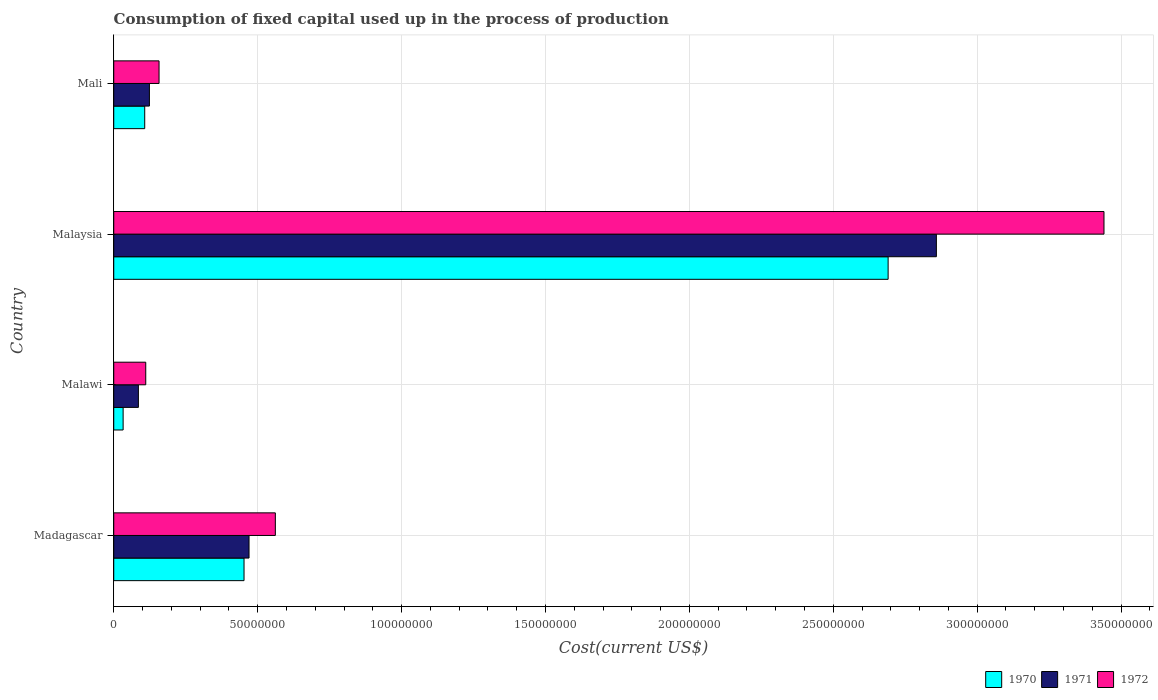How many different coloured bars are there?
Keep it short and to the point. 3. What is the label of the 4th group of bars from the top?
Provide a short and direct response. Madagascar. In how many cases, is the number of bars for a given country not equal to the number of legend labels?
Ensure brevity in your answer.  0. What is the amount consumed in the process of production in 1972 in Mali?
Your response must be concise. 1.57e+07. Across all countries, what is the maximum amount consumed in the process of production in 1971?
Give a very brief answer. 2.86e+08. Across all countries, what is the minimum amount consumed in the process of production in 1970?
Keep it short and to the point. 3.26e+06. In which country was the amount consumed in the process of production in 1970 maximum?
Give a very brief answer. Malaysia. In which country was the amount consumed in the process of production in 1971 minimum?
Your answer should be compact. Malawi. What is the total amount consumed in the process of production in 1970 in the graph?
Your response must be concise. 3.28e+08. What is the difference between the amount consumed in the process of production in 1972 in Madagascar and that in Mali?
Your answer should be compact. 4.04e+07. What is the difference between the amount consumed in the process of production in 1972 in Malaysia and the amount consumed in the process of production in 1971 in Madagascar?
Offer a very short reply. 2.97e+08. What is the average amount consumed in the process of production in 1972 per country?
Your response must be concise. 1.07e+08. What is the difference between the amount consumed in the process of production in 1972 and amount consumed in the process of production in 1970 in Madagascar?
Ensure brevity in your answer.  1.09e+07. In how many countries, is the amount consumed in the process of production in 1972 greater than 60000000 US$?
Your answer should be very brief. 1. What is the ratio of the amount consumed in the process of production in 1970 in Malawi to that in Malaysia?
Ensure brevity in your answer.  0.01. Is the amount consumed in the process of production in 1972 in Malawi less than that in Mali?
Your answer should be compact. Yes. Is the difference between the amount consumed in the process of production in 1972 in Malawi and Mali greater than the difference between the amount consumed in the process of production in 1970 in Malawi and Mali?
Your answer should be very brief. Yes. What is the difference between the highest and the second highest amount consumed in the process of production in 1972?
Provide a succinct answer. 2.88e+08. What is the difference between the highest and the lowest amount consumed in the process of production in 1970?
Offer a very short reply. 2.66e+08. In how many countries, is the amount consumed in the process of production in 1970 greater than the average amount consumed in the process of production in 1970 taken over all countries?
Offer a very short reply. 1. What does the 2nd bar from the top in Malawi represents?
Ensure brevity in your answer.  1971. Is it the case that in every country, the sum of the amount consumed in the process of production in 1971 and amount consumed in the process of production in 1970 is greater than the amount consumed in the process of production in 1972?
Your response must be concise. Yes. How many bars are there?
Your response must be concise. 12. How many countries are there in the graph?
Offer a very short reply. 4. What is the difference between two consecutive major ticks on the X-axis?
Provide a succinct answer. 5.00e+07. Does the graph contain any zero values?
Keep it short and to the point. No. Does the graph contain grids?
Offer a very short reply. Yes. Where does the legend appear in the graph?
Keep it short and to the point. Bottom right. How are the legend labels stacked?
Give a very brief answer. Horizontal. What is the title of the graph?
Provide a short and direct response. Consumption of fixed capital used up in the process of production. Does "1966" appear as one of the legend labels in the graph?
Your response must be concise. No. What is the label or title of the X-axis?
Offer a very short reply. Cost(current US$). What is the Cost(current US$) in 1970 in Madagascar?
Your answer should be very brief. 4.53e+07. What is the Cost(current US$) of 1971 in Madagascar?
Keep it short and to the point. 4.70e+07. What is the Cost(current US$) of 1972 in Madagascar?
Give a very brief answer. 5.61e+07. What is the Cost(current US$) of 1970 in Malawi?
Your response must be concise. 3.26e+06. What is the Cost(current US$) in 1971 in Malawi?
Make the answer very short. 8.56e+06. What is the Cost(current US$) in 1972 in Malawi?
Keep it short and to the point. 1.11e+07. What is the Cost(current US$) in 1970 in Malaysia?
Your response must be concise. 2.69e+08. What is the Cost(current US$) in 1971 in Malaysia?
Offer a terse response. 2.86e+08. What is the Cost(current US$) in 1972 in Malaysia?
Provide a succinct answer. 3.44e+08. What is the Cost(current US$) of 1970 in Mali?
Keep it short and to the point. 1.08e+07. What is the Cost(current US$) of 1971 in Mali?
Give a very brief answer. 1.24e+07. What is the Cost(current US$) of 1972 in Mali?
Your response must be concise. 1.57e+07. Across all countries, what is the maximum Cost(current US$) in 1970?
Ensure brevity in your answer.  2.69e+08. Across all countries, what is the maximum Cost(current US$) of 1971?
Your answer should be compact. 2.86e+08. Across all countries, what is the maximum Cost(current US$) of 1972?
Provide a short and direct response. 3.44e+08. Across all countries, what is the minimum Cost(current US$) in 1970?
Provide a succinct answer. 3.26e+06. Across all countries, what is the minimum Cost(current US$) of 1971?
Make the answer very short. 8.56e+06. Across all countries, what is the minimum Cost(current US$) of 1972?
Offer a very short reply. 1.11e+07. What is the total Cost(current US$) of 1970 in the graph?
Provide a succinct answer. 3.28e+08. What is the total Cost(current US$) of 1971 in the graph?
Keep it short and to the point. 3.54e+08. What is the total Cost(current US$) in 1972 in the graph?
Your response must be concise. 4.27e+08. What is the difference between the Cost(current US$) of 1970 in Madagascar and that in Malawi?
Your response must be concise. 4.20e+07. What is the difference between the Cost(current US$) in 1971 in Madagascar and that in Malawi?
Ensure brevity in your answer.  3.84e+07. What is the difference between the Cost(current US$) in 1972 in Madagascar and that in Malawi?
Make the answer very short. 4.50e+07. What is the difference between the Cost(current US$) of 1970 in Madagascar and that in Malaysia?
Provide a short and direct response. -2.24e+08. What is the difference between the Cost(current US$) of 1971 in Madagascar and that in Malaysia?
Offer a very short reply. -2.39e+08. What is the difference between the Cost(current US$) in 1972 in Madagascar and that in Malaysia?
Give a very brief answer. -2.88e+08. What is the difference between the Cost(current US$) of 1970 in Madagascar and that in Mali?
Offer a very short reply. 3.45e+07. What is the difference between the Cost(current US$) in 1971 in Madagascar and that in Mali?
Ensure brevity in your answer.  3.46e+07. What is the difference between the Cost(current US$) of 1972 in Madagascar and that in Mali?
Make the answer very short. 4.04e+07. What is the difference between the Cost(current US$) of 1970 in Malawi and that in Malaysia?
Your response must be concise. -2.66e+08. What is the difference between the Cost(current US$) of 1971 in Malawi and that in Malaysia?
Offer a terse response. -2.77e+08. What is the difference between the Cost(current US$) of 1972 in Malawi and that in Malaysia?
Ensure brevity in your answer.  -3.33e+08. What is the difference between the Cost(current US$) in 1970 in Malawi and that in Mali?
Provide a short and direct response. -7.50e+06. What is the difference between the Cost(current US$) in 1971 in Malawi and that in Mali?
Your response must be concise. -3.83e+06. What is the difference between the Cost(current US$) of 1972 in Malawi and that in Mali?
Make the answer very short. -4.62e+06. What is the difference between the Cost(current US$) in 1970 in Malaysia and that in Mali?
Your answer should be compact. 2.58e+08. What is the difference between the Cost(current US$) in 1971 in Malaysia and that in Mali?
Your response must be concise. 2.73e+08. What is the difference between the Cost(current US$) in 1972 in Malaysia and that in Mali?
Offer a terse response. 3.28e+08. What is the difference between the Cost(current US$) in 1970 in Madagascar and the Cost(current US$) in 1971 in Malawi?
Keep it short and to the point. 3.67e+07. What is the difference between the Cost(current US$) of 1970 in Madagascar and the Cost(current US$) of 1972 in Malawi?
Provide a succinct answer. 3.41e+07. What is the difference between the Cost(current US$) in 1971 in Madagascar and the Cost(current US$) in 1972 in Malawi?
Make the answer very short. 3.59e+07. What is the difference between the Cost(current US$) of 1970 in Madagascar and the Cost(current US$) of 1971 in Malaysia?
Your response must be concise. -2.41e+08. What is the difference between the Cost(current US$) in 1970 in Madagascar and the Cost(current US$) in 1972 in Malaysia?
Provide a succinct answer. -2.99e+08. What is the difference between the Cost(current US$) in 1971 in Madagascar and the Cost(current US$) in 1972 in Malaysia?
Your answer should be very brief. -2.97e+08. What is the difference between the Cost(current US$) in 1970 in Madagascar and the Cost(current US$) in 1971 in Mali?
Offer a very short reply. 3.29e+07. What is the difference between the Cost(current US$) in 1970 in Madagascar and the Cost(current US$) in 1972 in Mali?
Your answer should be compact. 2.95e+07. What is the difference between the Cost(current US$) of 1971 in Madagascar and the Cost(current US$) of 1972 in Mali?
Offer a very short reply. 3.13e+07. What is the difference between the Cost(current US$) of 1970 in Malawi and the Cost(current US$) of 1971 in Malaysia?
Your response must be concise. -2.83e+08. What is the difference between the Cost(current US$) in 1970 in Malawi and the Cost(current US$) in 1972 in Malaysia?
Your response must be concise. -3.41e+08. What is the difference between the Cost(current US$) of 1971 in Malawi and the Cost(current US$) of 1972 in Malaysia?
Your response must be concise. -3.35e+08. What is the difference between the Cost(current US$) of 1970 in Malawi and the Cost(current US$) of 1971 in Mali?
Your response must be concise. -9.13e+06. What is the difference between the Cost(current US$) of 1970 in Malawi and the Cost(current US$) of 1972 in Mali?
Your answer should be compact. -1.25e+07. What is the difference between the Cost(current US$) of 1971 in Malawi and the Cost(current US$) of 1972 in Mali?
Provide a succinct answer. -7.18e+06. What is the difference between the Cost(current US$) of 1970 in Malaysia and the Cost(current US$) of 1971 in Mali?
Make the answer very short. 2.57e+08. What is the difference between the Cost(current US$) of 1970 in Malaysia and the Cost(current US$) of 1972 in Mali?
Offer a very short reply. 2.53e+08. What is the difference between the Cost(current US$) of 1971 in Malaysia and the Cost(current US$) of 1972 in Mali?
Provide a succinct answer. 2.70e+08. What is the average Cost(current US$) in 1970 per country?
Offer a terse response. 8.21e+07. What is the average Cost(current US$) in 1971 per country?
Your answer should be compact. 8.84e+07. What is the average Cost(current US$) in 1972 per country?
Your answer should be compact. 1.07e+08. What is the difference between the Cost(current US$) of 1970 and Cost(current US$) of 1971 in Madagascar?
Keep it short and to the point. -1.74e+06. What is the difference between the Cost(current US$) in 1970 and Cost(current US$) in 1972 in Madagascar?
Your answer should be compact. -1.09e+07. What is the difference between the Cost(current US$) in 1971 and Cost(current US$) in 1972 in Madagascar?
Your response must be concise. -9.14e+06. What is the difference between the Cost(current US$) in 1970 and Cost(current US$) in 1971 in Malawi?
Offer a terse response. -5.30e+06. What is the difference between the Cost(current US$) in 1970 and Cost(current US$) in 1972 in Malawi?
Your answer should be compact. -7.86e+06. What is the difference between the Cost(current US$) of 1971 and Cost(current US$) of 1972 in Malawi?
Keep it short and to the point. -2.56e+06. What is the difference between the Cost(current US$) of 1970 and Cost(current US$) of 1971 in Malaysia?
Offer a very short reply. -1.68e+07. What is the difference between the Cost(current US$) in 1970 and Cost(current US$) in 1972 in Malaysia?
Give a very brief answer. -7.50e+07. What is the difference between the Cost(current US$) in 1971 and Cost(current US$) in 1972 in Malaysia?
Make the answer very short. -5.82e+07. What is the difference between the Cost(current US$) in 1970 and Cost(current US$) in 1971 in Mali?
Make the answer very short. -1.63e+06. What is the difference between the Cost(current US$) in 1970 and Cost(current US$) in 1972 in Mali?
Give a very brief answer. -4.98e+06. What is the difference between the Cost(current US$) of 1971 and Cost(current US$) of 1972 in Mali?
Provide a succinct answer. -3.35e+06. What is the ratio of the Cost(current US$) in 1970 in Madagascar to that in Malawi?
Your response must be concise. 13.88. What is the ratio of the Cost(current US$) of 1971 in Madagascar to that in Malawi?
Keep it short and to the point. 5.49. What is the ratio of the Cost(current US$) of 1972 in Madagascar to that in Malawi?
Give a very brief answer. 5.05. What is the ratio of the Cost(current US$) of 1970 in Madagascar to that in Malaysia?
Provide a succinct answer. 0.17. What is the ratio of the Cost(current US$) of 1971 in Madagascar to that in Malaysia?
Keep it short and to the point. 0.16. What is the ratio of the Cost(current US$) in 1972 in Madagascar to that in Malaysia?
Your answer should be compact. 0.16. What is the ratio of the Cost(current US$) of 1970 in Madagascar to that in Mali?
Offer a very short reply. 4.21. What is the ratio of the Cost(current US$) in 1971 in Madagascar to that in Mali?
Provide a succinct answer. 3.79. What is the ratio of the Cost(current US$) in 1972 in Madagascar to that in Mali?
Provide a short and direct response. 3.57. What is the ratio of the Cost(current US$) of 1970 in Malawi to that in Malaysia?
Keep it short and to the point. 0.01. What is the ratio of the Cost(current US$) in 1971 in Malawi to that in Malaysia?
Your response must be concise. 0.03. What is the ratio of the Cost(current US$) in 1972 in Malawi to that in Malaysia?
Provide a short and direct response. 0.03. What is the ratio of the Cost(current US$) in 1970 in Malawi to that in Mali?
Your answer should be very brief. 0.3. What is the ratio of the Cost(current US$) in 1971 in Malawi to that in Mali?
Offer a terse response. 0.69. What is the ratio of the Cost(current US$) of 1972 in Malawi to that in Mali?
Provide a succinct answer. 0.71. What is the ratio of the Cost(current US$) of 1970 in Malaysia to that in Mali?
Your answer should be very brief. 25. What is the ratio of the Cost(current US$) of 1971 in Malaysia to that in Mali?
Your response must be concise. 23.06. What is the ratio of the Cost(current US$) of 1972 in Malaysia to that in Mali?
Offer a very short reply. 21.86. What is the difference between the highest and the second highest Cost(current US$) in 1970?
Your answer should be compact. 2.24e+08. What is the difference between the highest and the second highest Cost(current US$) of 1971?
Give a very brief answer. 2.39e+08. What is the difference between the highest and the second highest Cost(current US$) in 1972?
Your response must be concise. 2.88e+08. What is the difference between the highest and the lowest Cost(current US$) of 1970?
Provide a short and direct response. 2.66e+08. What is the difference between the highest and the lowest Cost(current US$) in 1971?
Provide a succinct answer. 2.77e+08. What is the difference between the highest and the lowest Cost(current US$) in 1972?
Your answer should be compact. 3.33e+08. 